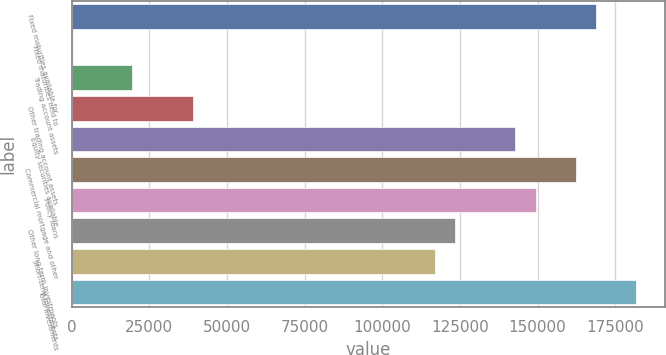Convert chart. <chart><loc_0><loc_0><loc_500><loc_500><bar_chart><fcel>Fixed maturities available for<fcel>Fixed maturities held to<fcel>Trading account assets<fcel>Other trading account assets<fcel>Equity securities available<fcel>Commercial mortgage and other<fcel>Policy loans<fcel>Other long-term investments<fcel>Short-term investments<fcel>Total investments<nl><fcel>168820<fcel>2.31<fcel>19481.2<fcel>38960.1<fcel>142848<fcel>162327<fcel>149341<fcel>123369<fcel>116876<fcel>181805<nl></chart> 